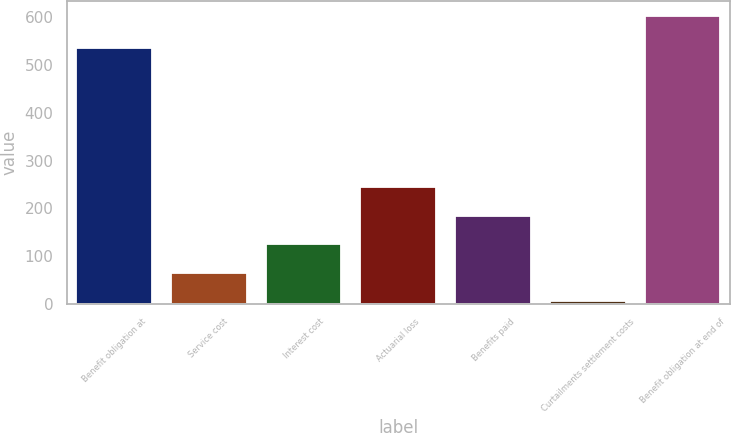Convert chart. <chart><loc_0><loc_0><loc_500><loc_500><bar_chart><fcel>Benefit obligation at<fcel>Service cost<fcel>Interest cost<fcel>Actuarial loss<fcel>Benefits paid<fcel>Curtailments settlement costs<fcel>Benefit obligation at end of<nl><fcel>536.3<fcel>65.57<fcel>125.24<fcel>244.58<fcel>184.91<fcel>5.9<fcel>602.6<nl></chart> 